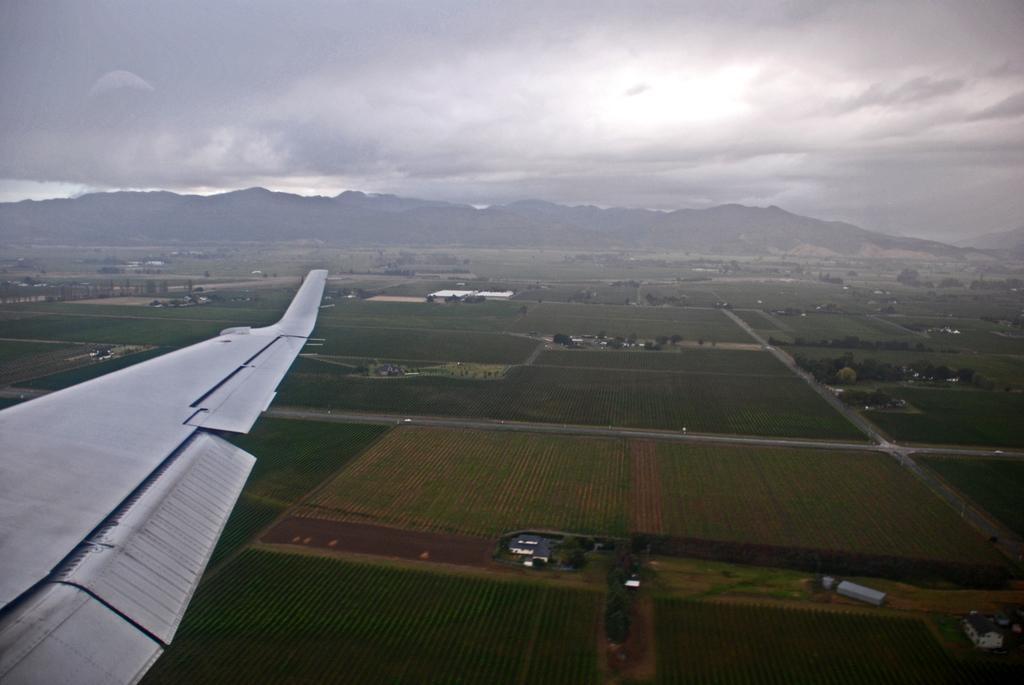Describe this image in one or two sentences. On the left corner of the image there is a wing of a flight. On the ground there are fields and there is grass. And also there are trees. In the background there are hills. At the top of the image there is sky with clouds. 